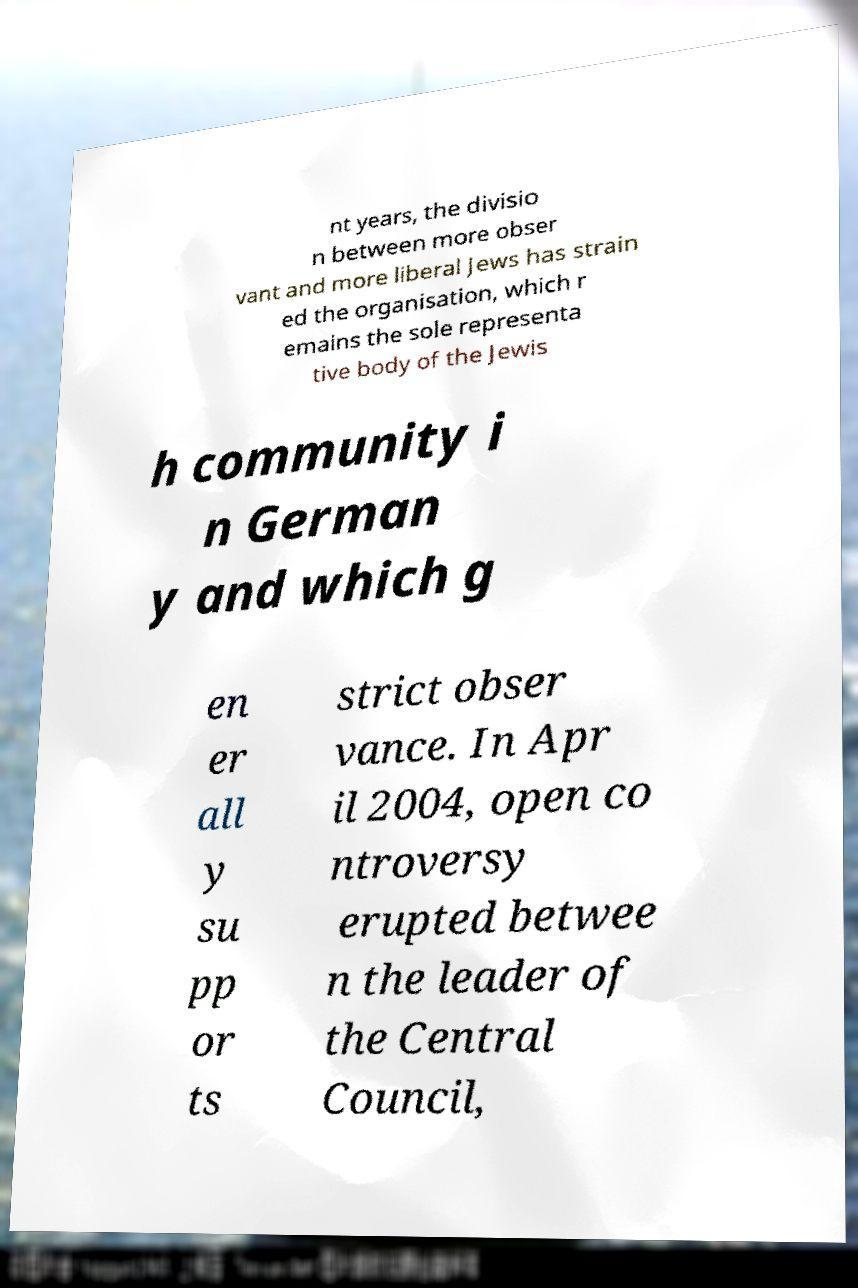Can you read and provide the text displayed in the image?This photo seems to have some interesting text. Can you extract and type it out for me? nt years, the divisio n between more obser vant and more liberal Jews has strain ed the organisation, which r emains the sole representa tive body of the Jewis h community i n German y and which g en er all y su pp or ts strict obser vance. In Apr il 2004, open co ntroversy erupted betwee n the leader of the Central Council, 